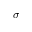<formula> <loc_0><loc_0><loc_500><loc_500>\sigma</formula> 